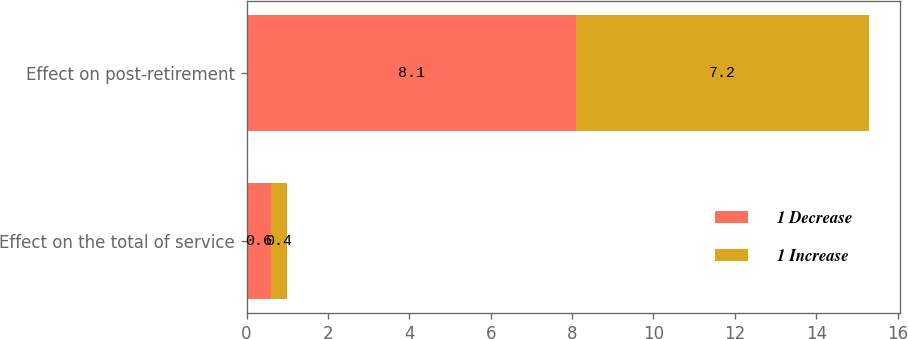Convert chart. <chart><loc_0><loc_0><loc_500><loc_500><stacked_bar_chart><ecel><fcel>Effect on the total of service<fcel>Effect on post-retirement<nl><fcel>1 Decrease<fcel>0.6<fcel>8.1<nl><fcel>1 Increase<fcel>0.4<fcel>7.2<nl></chart> 